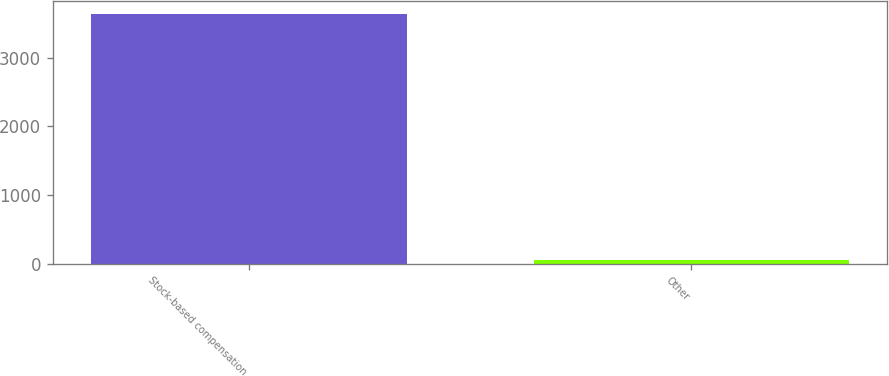Convert chart to OTSL. <chart><loc_0><loc_0><loc_500><loc_500><bar_chart><fcel>Stock-based compensation<fcel>Other<nl><fcel>3644<fcel>56<nl></chart> 